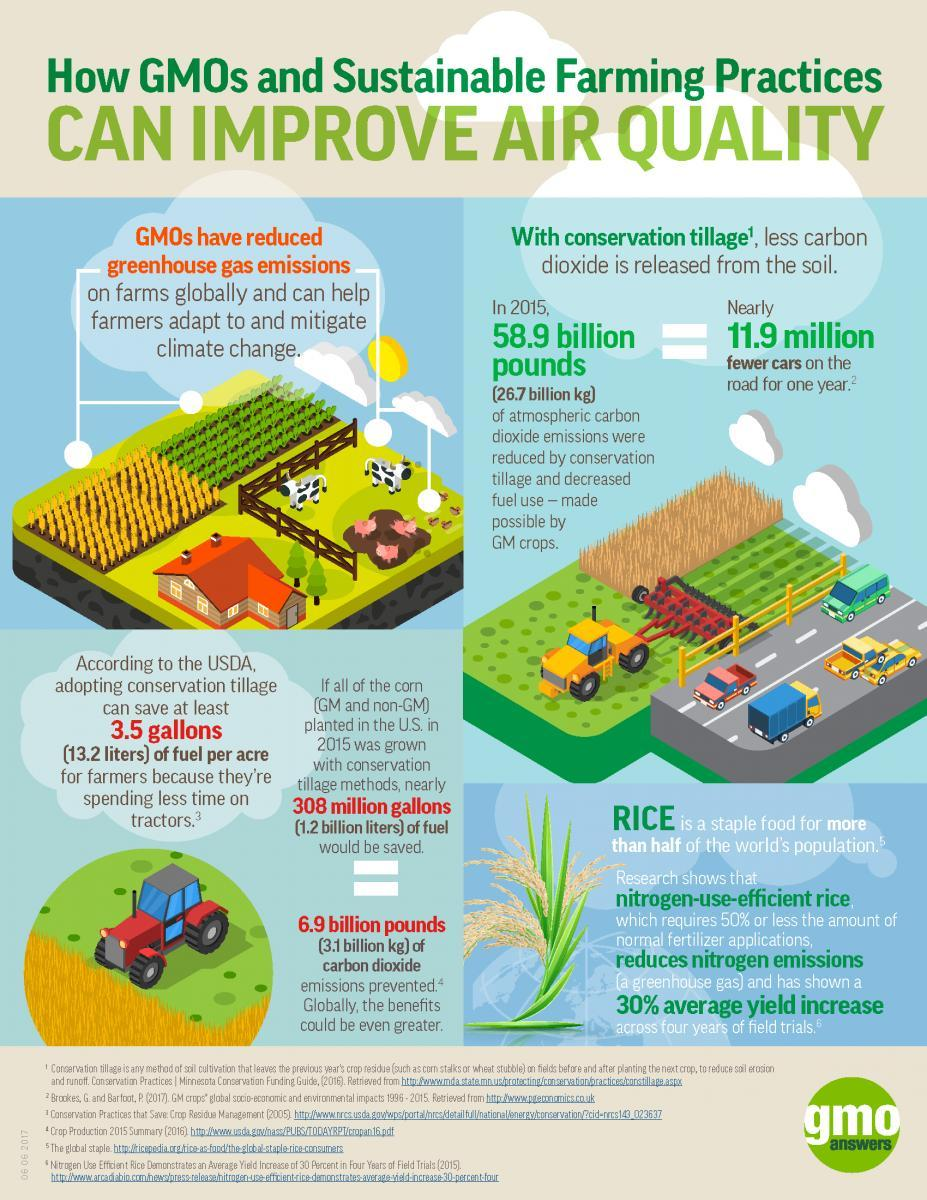How many vehicles are in this infographic?
Answer the question with a short phrase. 7 How many houses are in this infographic? 1 How many cows are in this infographic? 2 